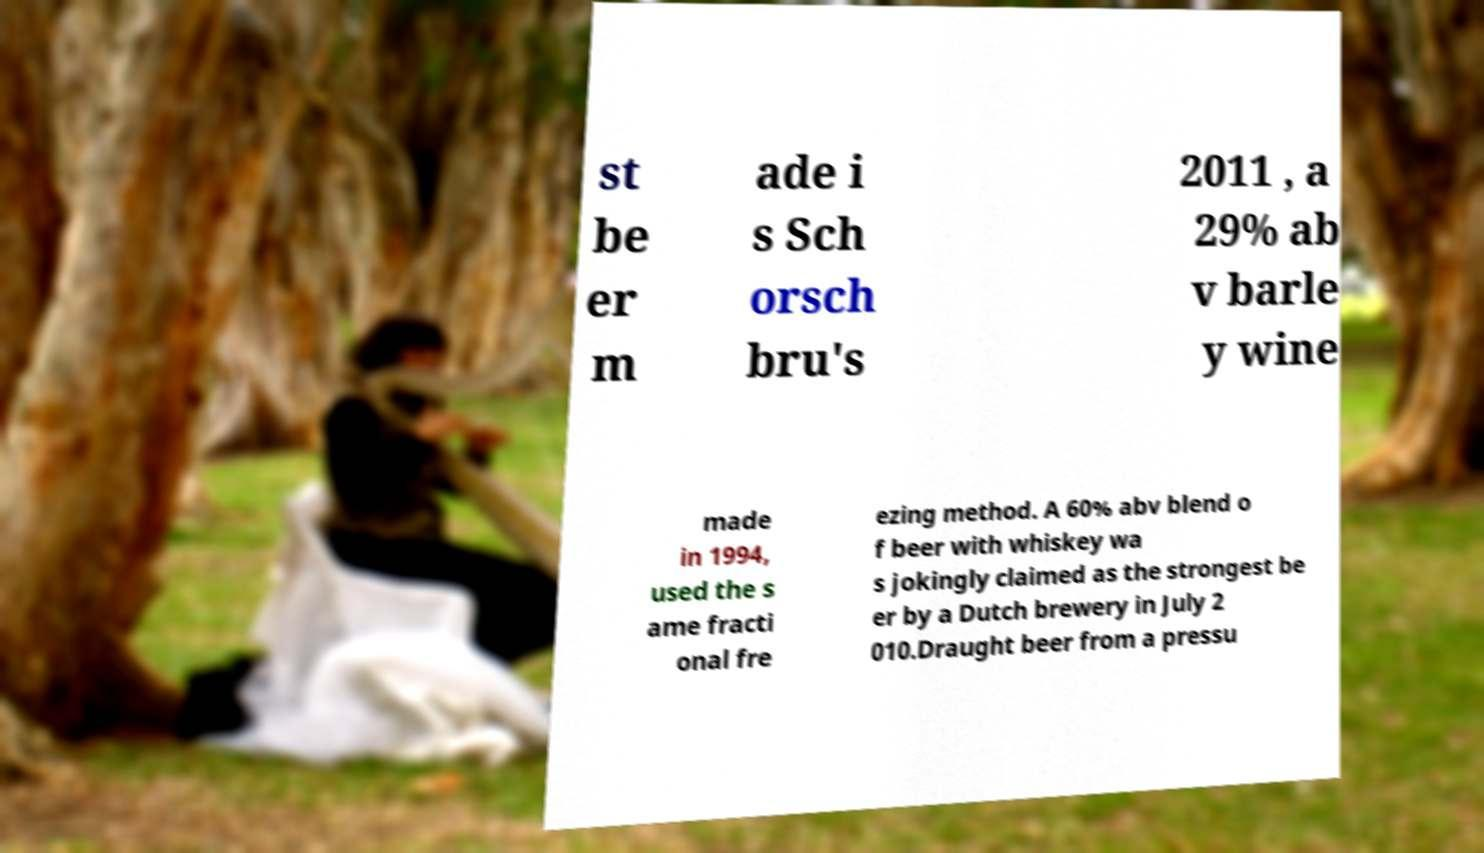Please read and relay the text visible in this image. What does it say? st be er m ade i s Sch orsch bru's 2011 , a 29% ab v barle y wine made in 1994, used the s ame fracti onal fre ezing method. A 60% abv blend o f beer with whiskey wa s jokingly claimed as the strongest be er by a Dutch brewery in July 2 010.Draught beer from a pressu 